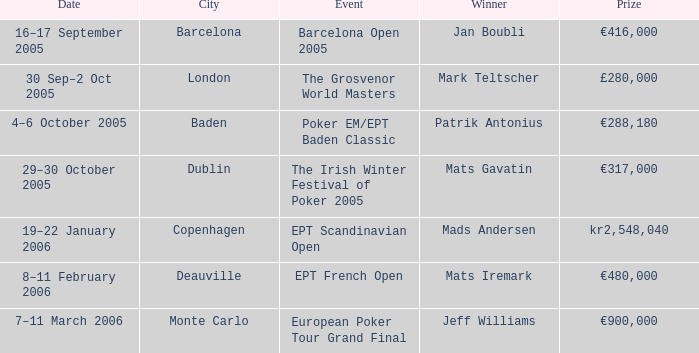Which occasion was won by mark teltscher? The Grosvenor World Masters. 